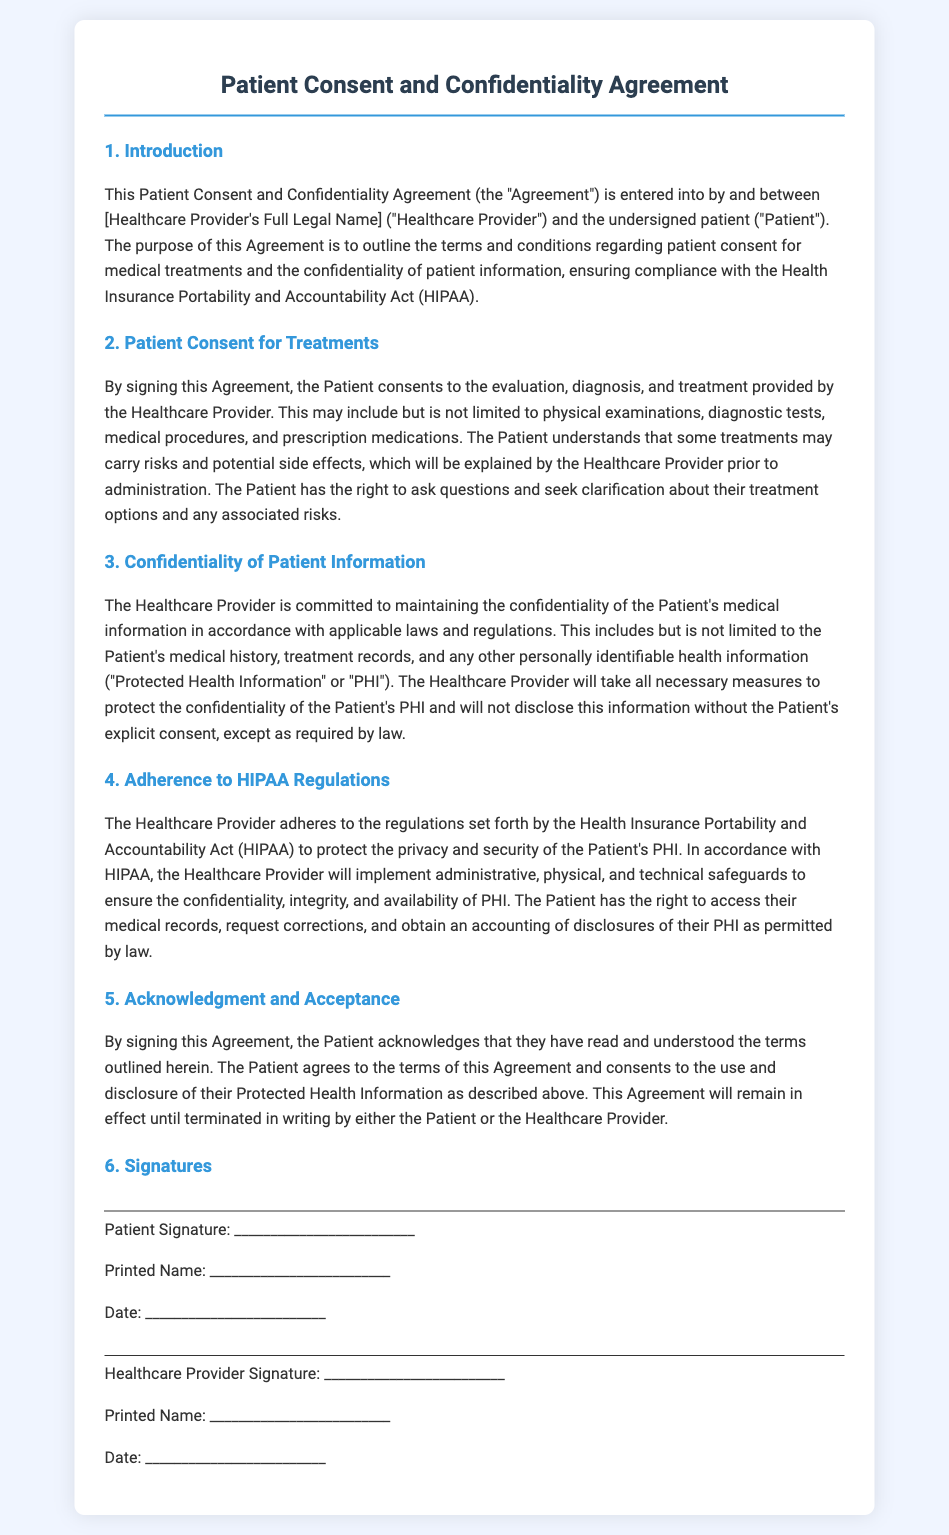what is the title of the document? The title is found at the top of the document in the main heading.
Answer: Patient Consent and Confidentiality Agreement who are the parties involved in the Agreement? The document specifies the parties in the introduction section.
Answer: Healthcare Provider and Patient what does the Patient consent to in section 2? The section outlines what the Patient consents to regarding treatments.
Answer: evaluation, diagnosis, and treatment what does PHI stand for in the document? The abbreviation PHI is defined in the context of patient information.
Answer: Protected Health Information which law does the Healthcare Provider adhere to for confidentiality? The specific regulation mentioned in section 4 concerning patient information confidentiality.
Answer: HIPAA what must the Patient do to have access to their medical records? The document states the Patient’s rights related to their medical records.
Answer: request corrections what happens if either party wants to terminate the Agreement? The end of the document explains how the Agreement can be ended.
Answer: terminated in writing what must the Healthcare Provider explain prior to treatment? The document specifies what information must be communicated by the Healthcare Provider.
Answer: risks and potential side effects how many signatures are required on the Agreement? The section on signatures details the number of signatures needed.
Answer: two 